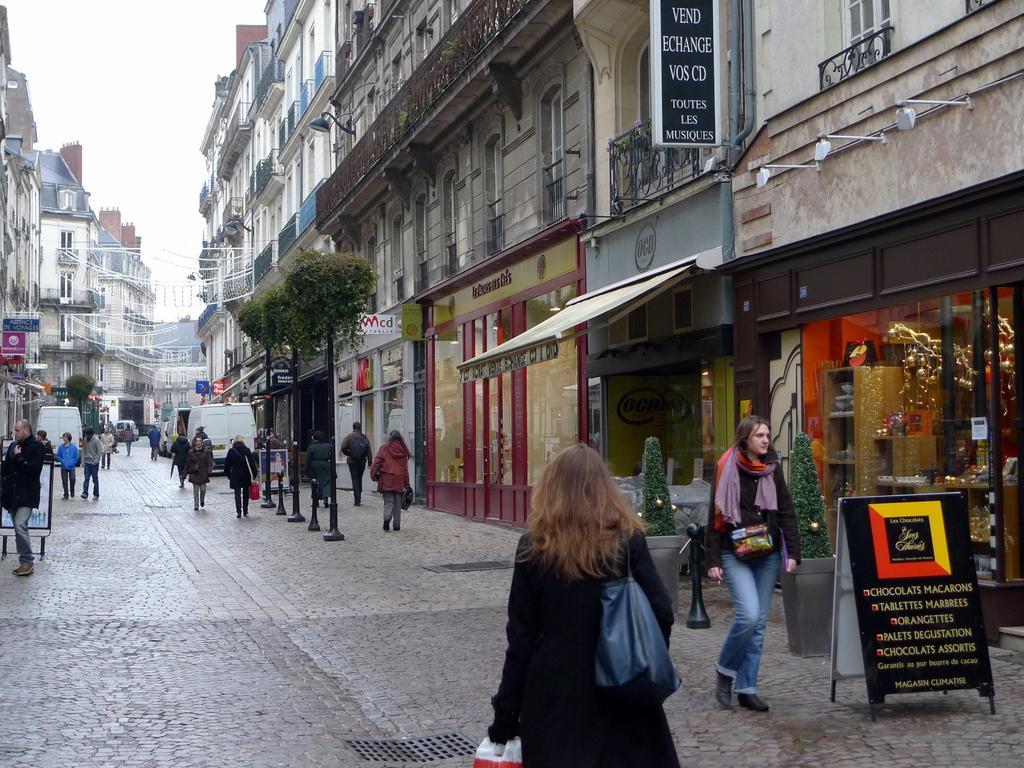Could you give a brief overview of what you see in this image? In this image I can see few buildings, windows, trees, poles, stores, colorful boards, vehicles, lights, flower pots, railing, pipes and few people are walking on the road. The sky is in white color. 